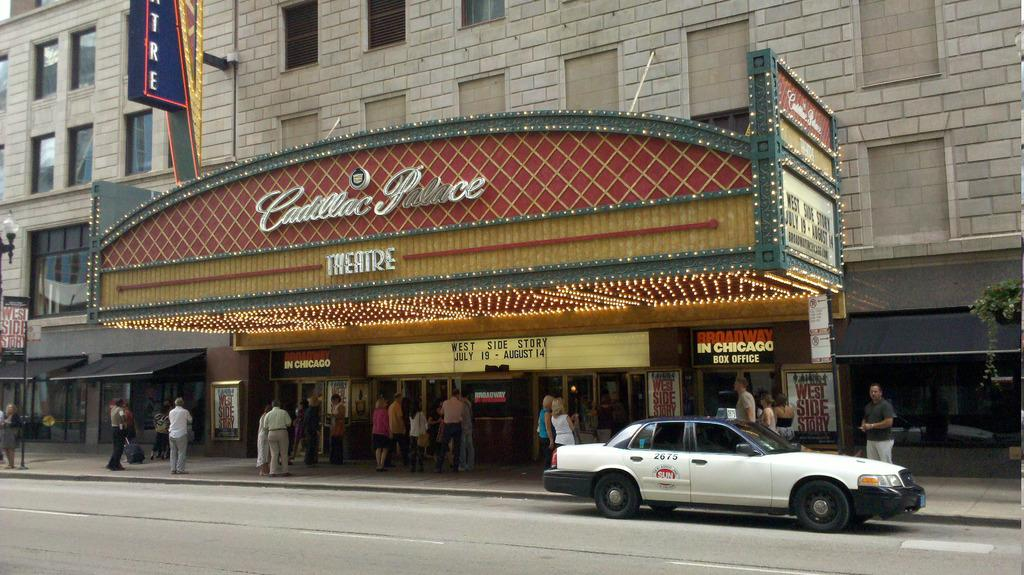Who or what can be seen in the image? There are people in the image. What is the primary setting of the image? There is a road in the image. What type of transportation is present in the image? There is a vehicle in the image. What type of establishments can be seen in the image? There are stores in the image. What type of signs are present in the image? There are boards with text in the image. What type of structures are present in the image? There are poles in the image. What type of illumination is present in the image? There are lights in the image. What type of natural elements are present in the image? There are plants in the image. Can you tell me how many apples are hanging from the poles in the image? There are no apples present in the image; only lights and boards with text are attached to the poles. What type of appliance is being used by the people in the image? There is no appliance visible in the image; the people are not using any tools or devices. 